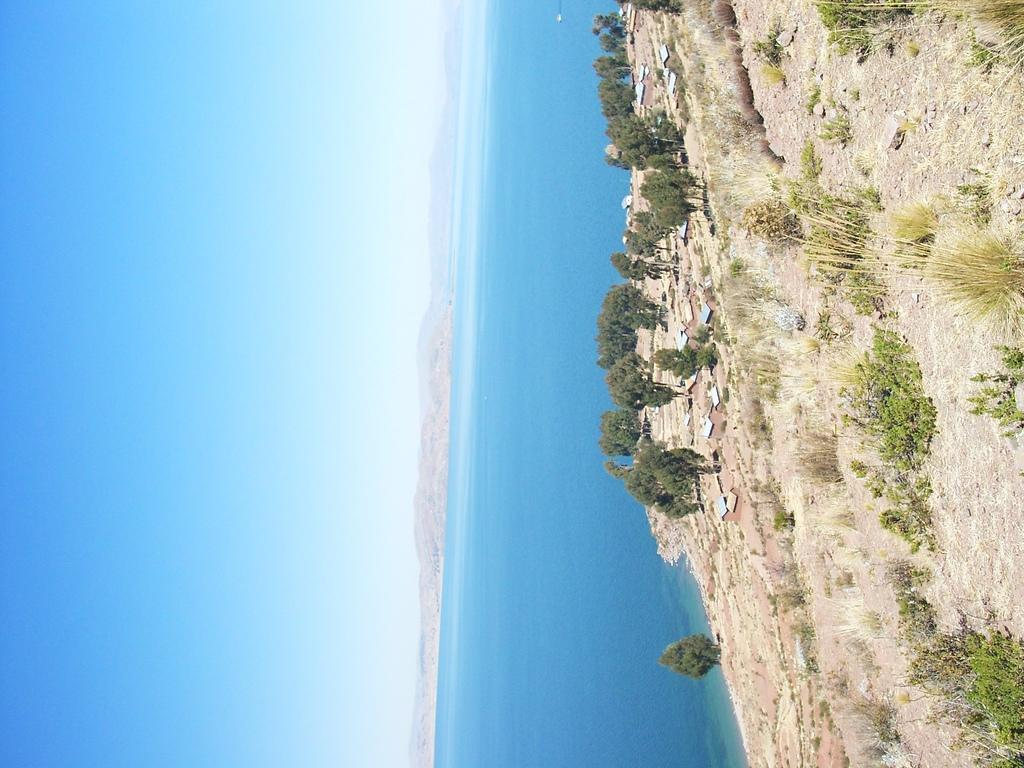What type of vegetation is on the right side of the image? There are plants, grass, and trees on the right side of the image. What can be seen in the middle of the image? There is water in the middle of the image. What is visible on the left side of the image? The sky is visible on the left side of the image. How does the increase in goldfish population affect the water in the image? There are no goldfish present in the image, so it is not possible to determine how their population might affect the water. 